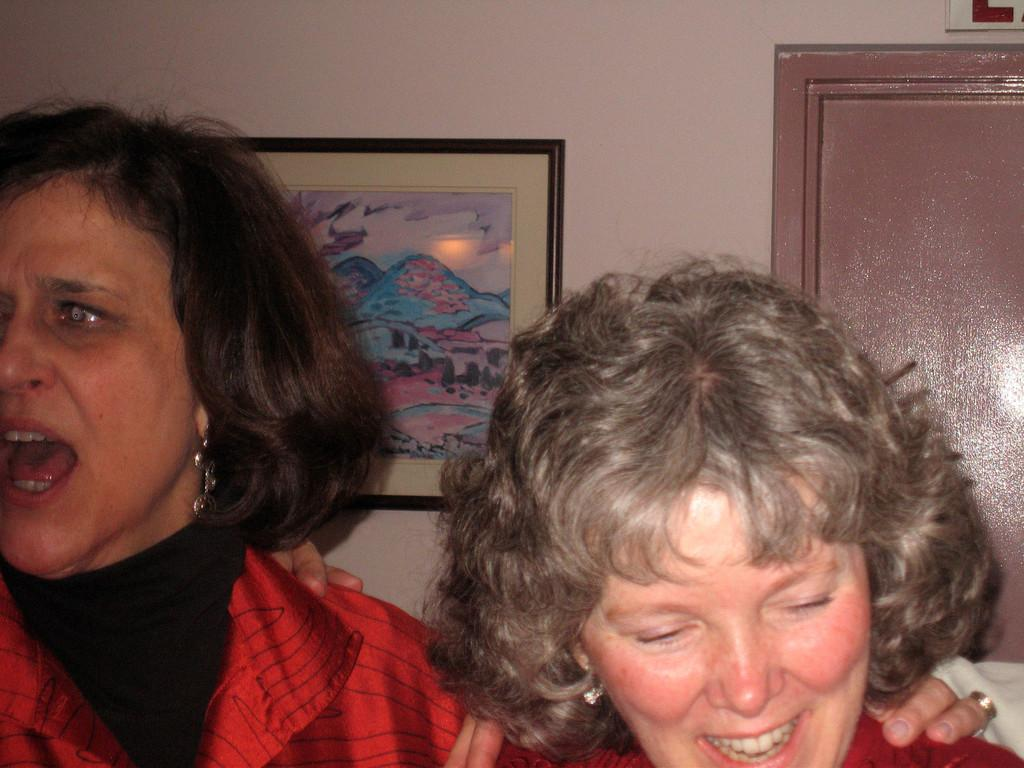How many people are in the image? There are two women in the image. What can be seen in the background of the image? There is a wall, a frame, a door, and a board in the background of the image. Can you describe the board in the background? The board in the background is truncated, meaning it is partially visible. How deep is the hole in the image? There is no hole present in the image. What is the nature of the love between the two women in the image? The nature of their love cannot be determined from the image, as it does not provide any information about their relationship. 